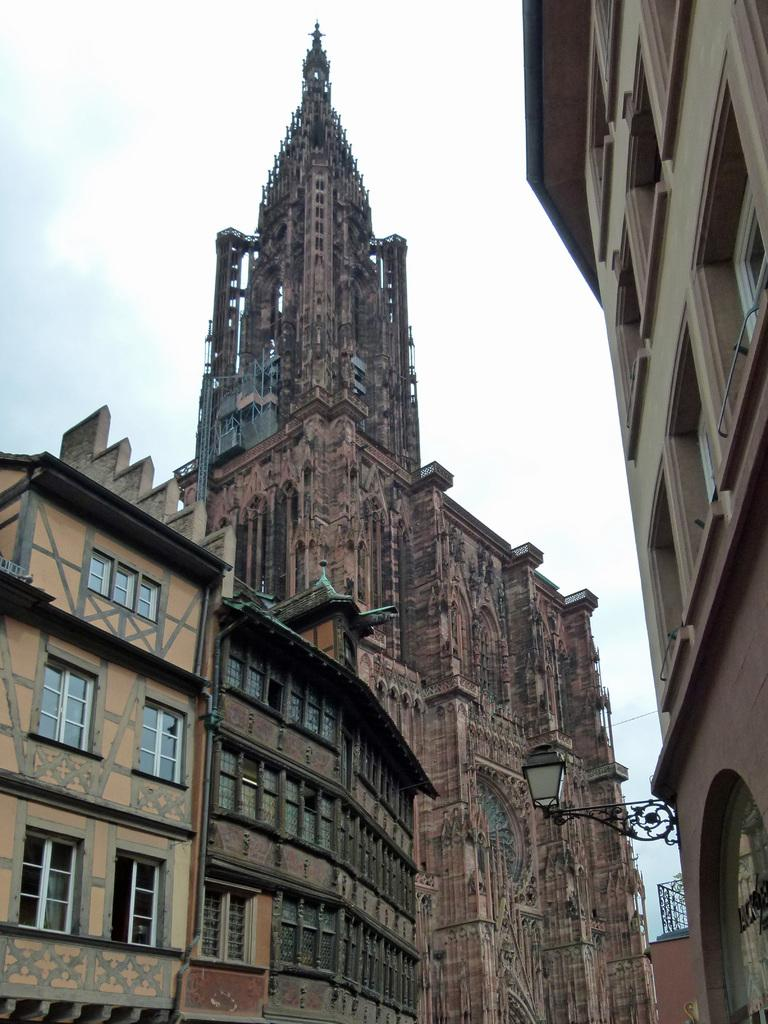What type of structures are present in the image? There are buildings in the image. Can you describe any specific features of the buildings? One of the buildings has a light on it. What can be seen in the background of the image? The sky is visible in the background of the image. What type of milk is being served in the image? There is no milk present in the image; it features buildings with a light and a visible sky in the background. 